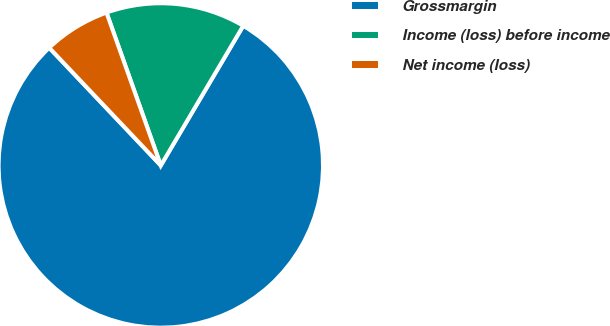<chart> <loc_0><loc_0><loc_500><loc_500><pie_chart><fcel>Grossmargin<fcel>Income (loss) before income<fcel>Net income (loss)<nl><fcel>79.44%<fcel>13.92%<fcel>6.64%<nl></chart> 